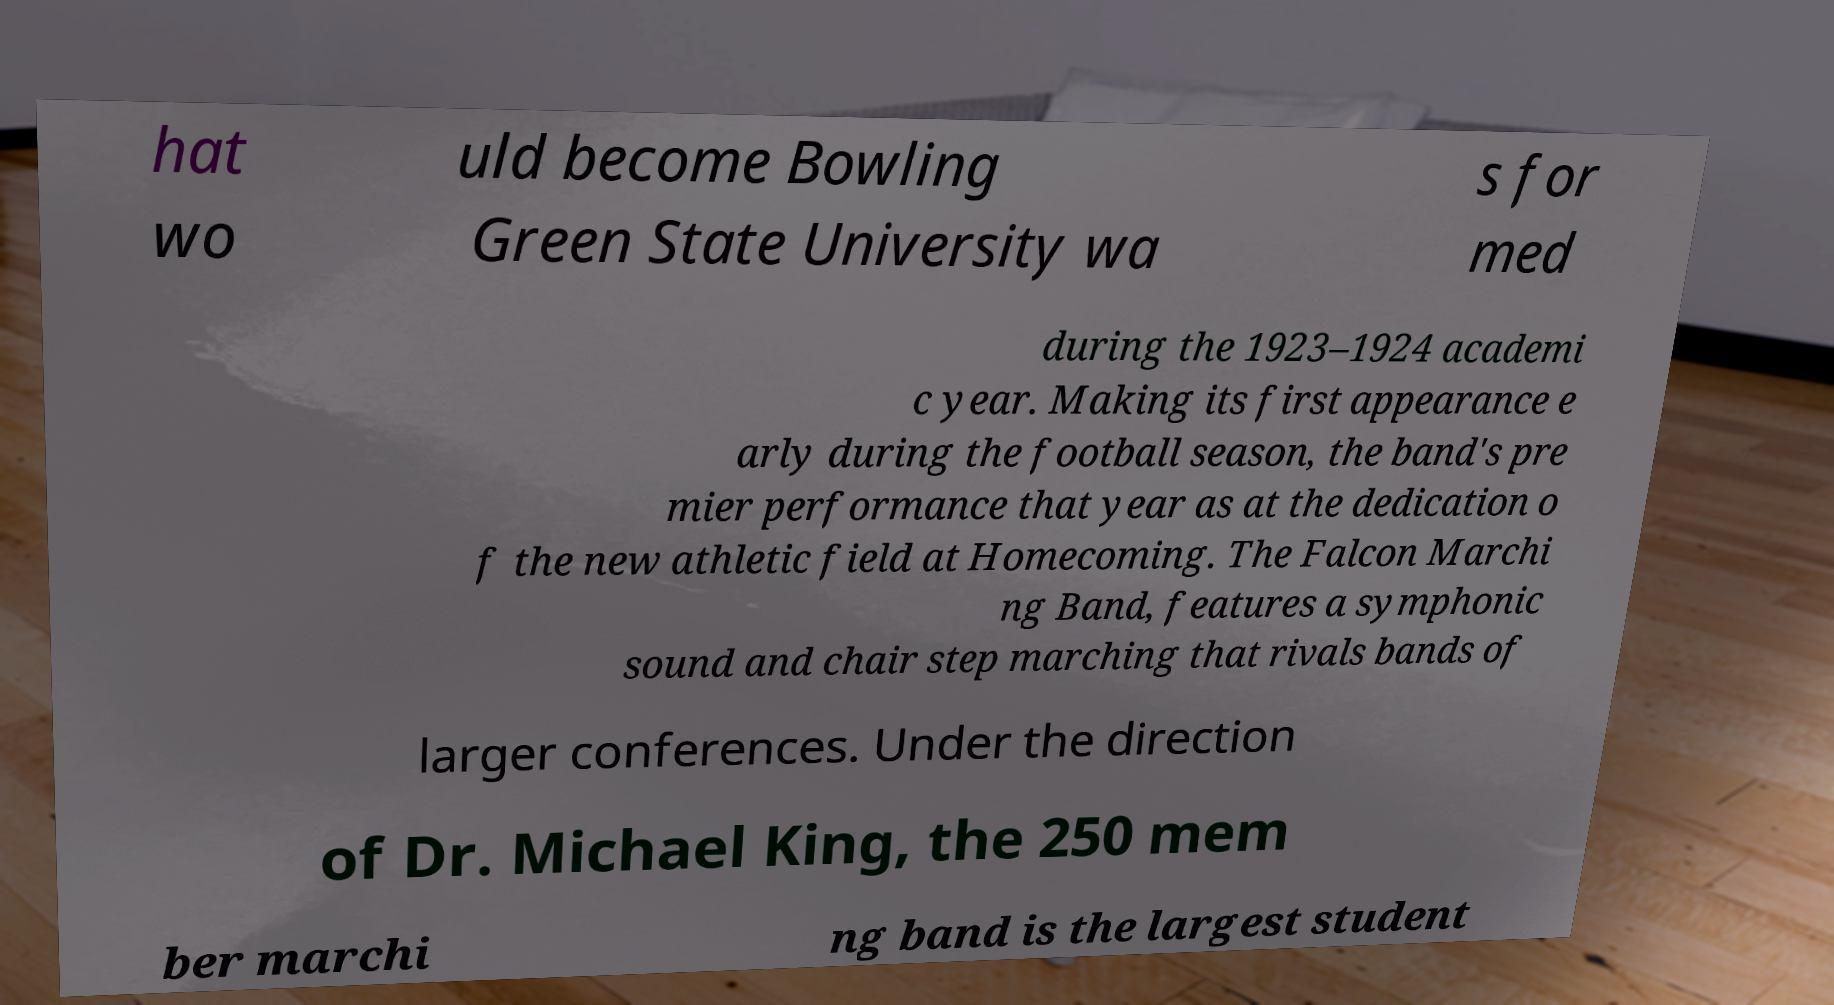Can you accurately transcribe the text from the provided image for me? hat wo uld become Bowling Green State University wa s for med during the 1923–1924 academi c year. Making its first appearance e arly during the football season, the band's pre mier performance that year as at the dedication o f the new athletic field at Homecoming. The Falcon Marchi ng Band, features a symphonic sound and chair step marching that rivals bands of larger conferences. Under the direction of Dr. Michael King, the 250 mem ber marchi ng band is the largest student 